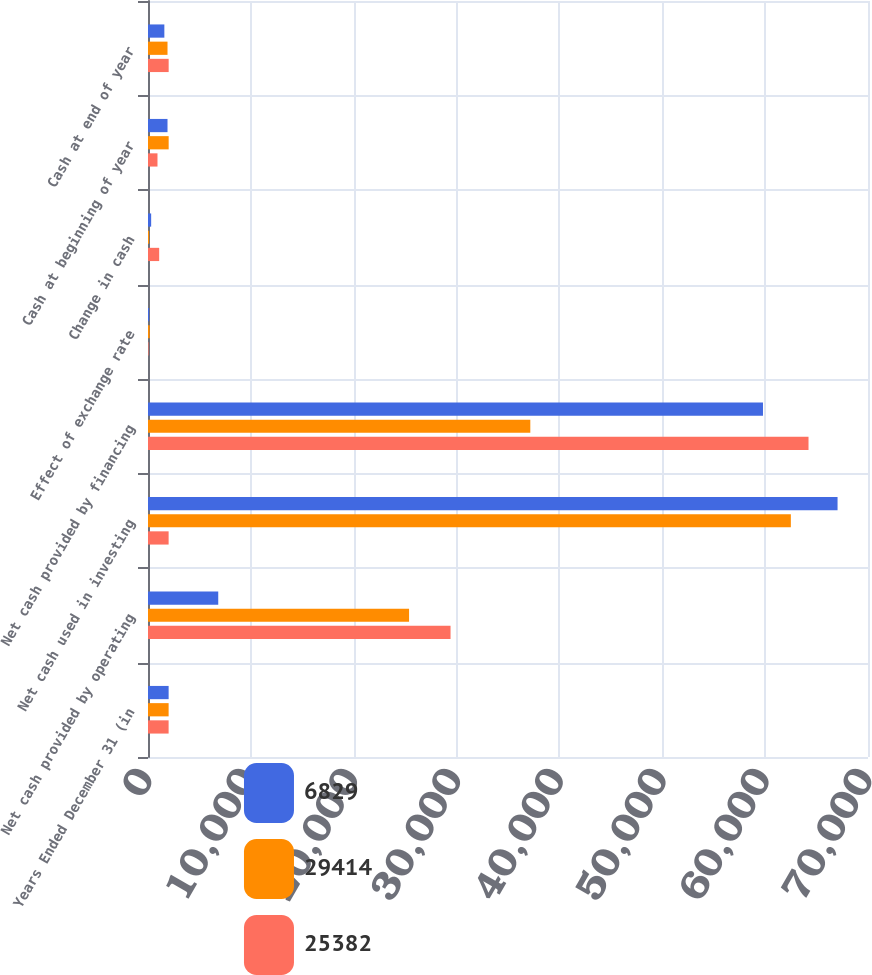Convert chart. <chart><loc_0><loc_0><loc_500><loc_500><stacked_bar_chart><ecel><fcel>Years Ended December 31 (in<fcel>Net cash provided by operating<fcel>Net cash used in investing<fcel>Net cash provided by financing<fcel>Effect of exchange rate<fcel>Change in cash<fcel>Cash at beginning of year<fcel>Cash at end of year<nl><fcel>6829<fcel>2006<fcel>6829<fcel>67040<fcel>59790<fcel>114<fcel>307<fcel>1897<fcel>1590<nl><fcel>29414<fcel>2005<fcel>25382<fcel>62500<fcel>37169<fcel>163<fcel>112<fcel>2009<fcel>1897<nl><fcel>25382<fcel>2004<fcel>29414<fcel>2005<fcel>64217<fcel>52<fcel>1087<fcel>922<fcel>2009<nl></chart> 